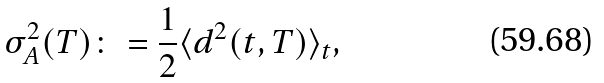<formula> <loc_0><loc_0><loc_500><loc_500>\sigma ^ { 2 } _ { A } ( T ) \colon = \frac { 1 } { 2 } \langle d ^ { 2 } ( t , T ) \rangle _ { t } ,</formula> 